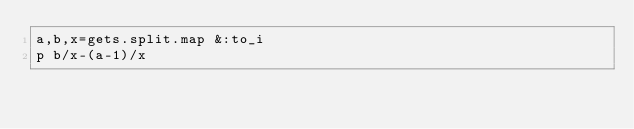Convert code to text. <code><loc_0><loc_0><loc_500><loc_500><_Ruby_>a,b,x=gets.split.map &:to_i
p b/x-(a-1)/x</code> 